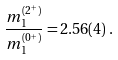Convert formula to latex. <formula><loc_0><loc_0><loc_500><loc_500>\frac { m _ { 1 } ^ { ( 2 ^ { + } ) } } { m _ { 1 } ^ { ( 0 ^ { + } ) } } = 2 . 5 6 ( 4 ) \, .</formula> 